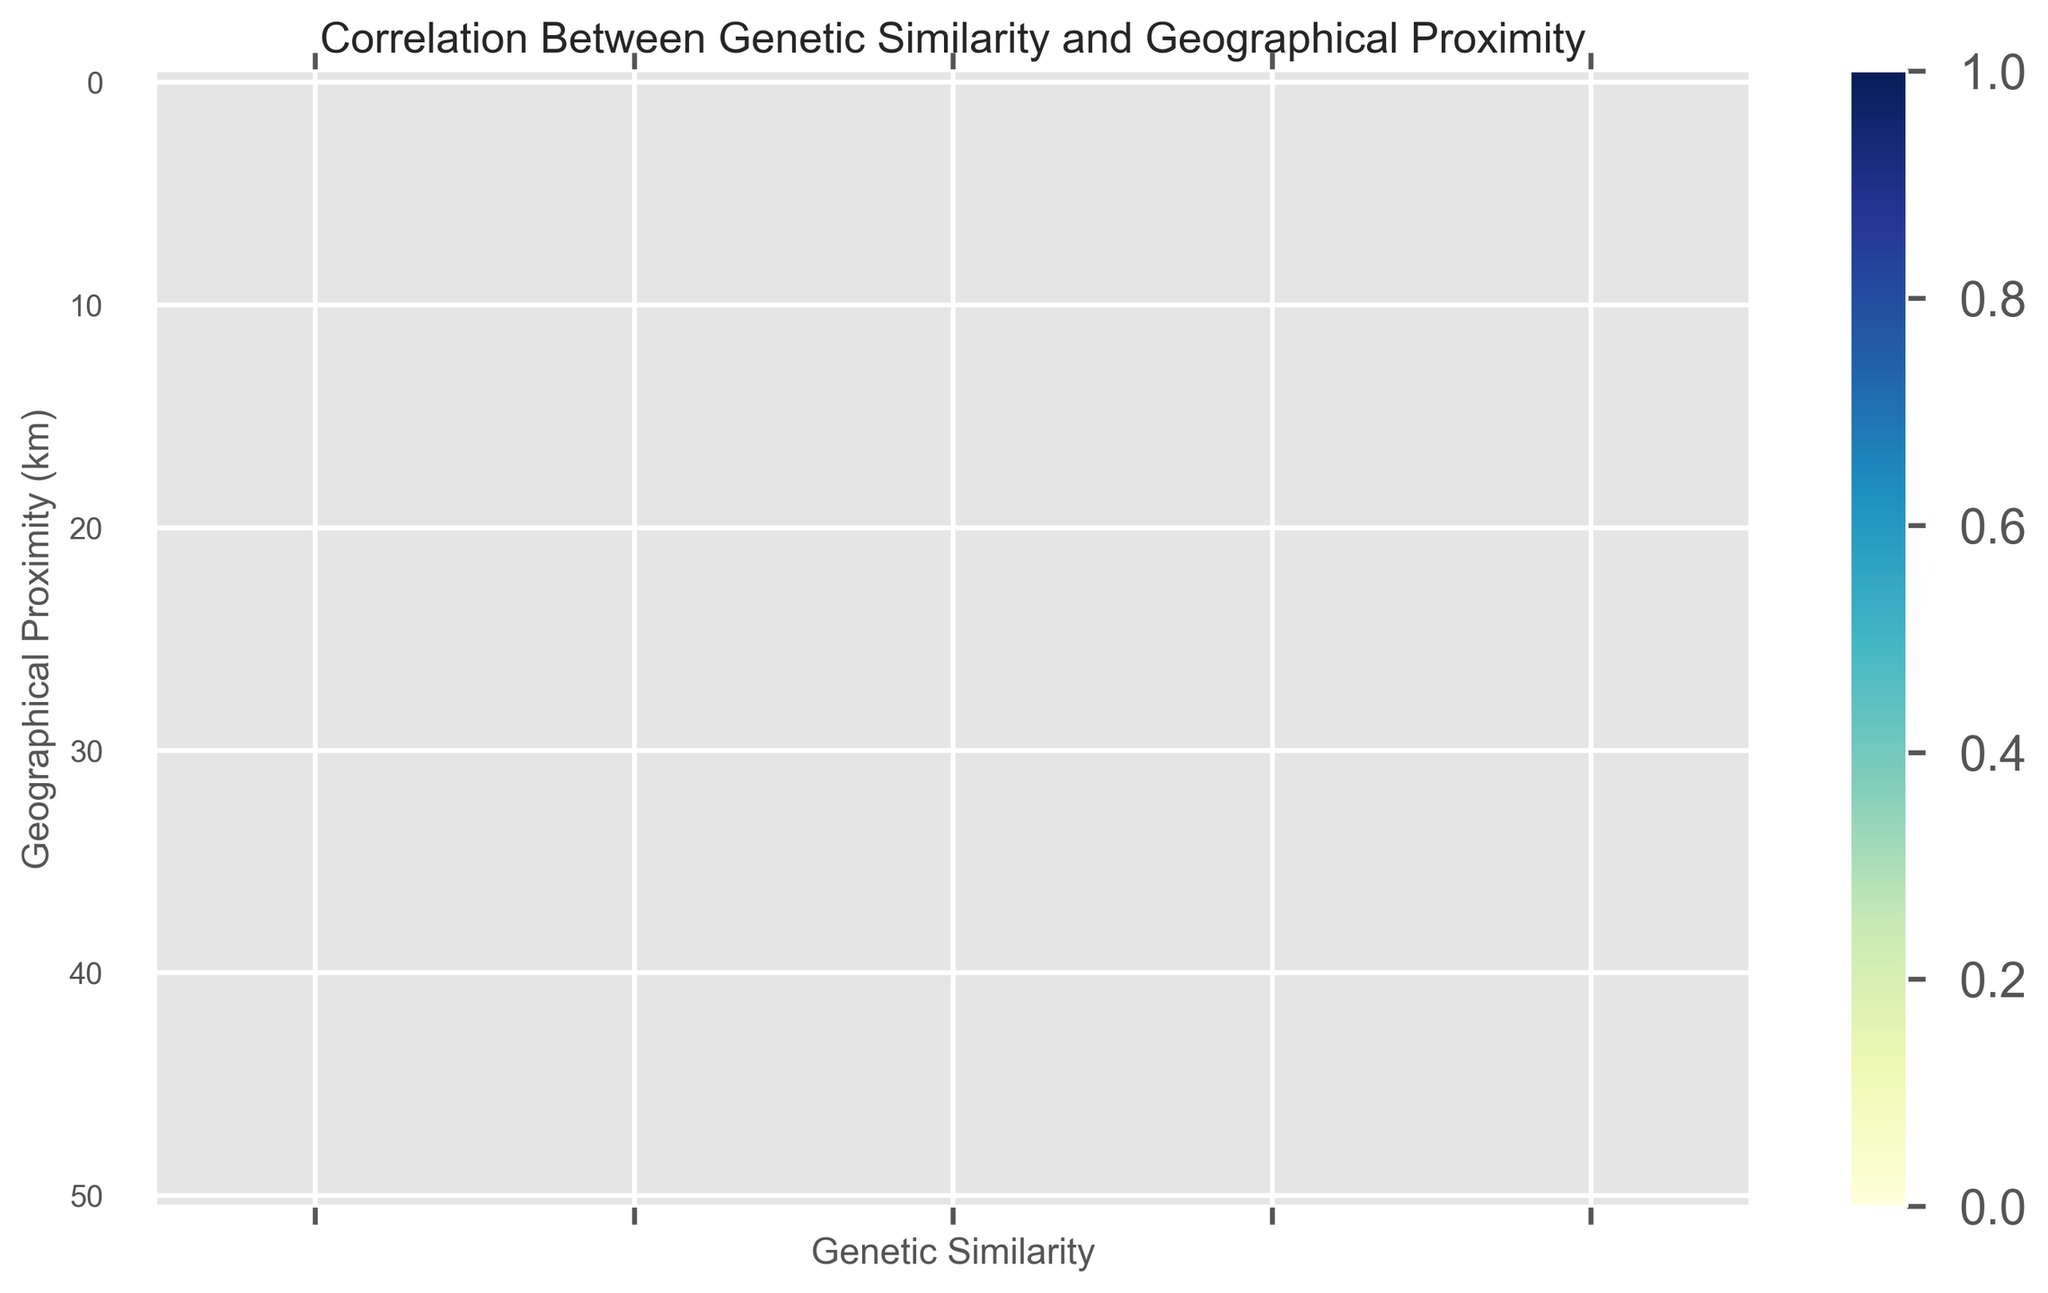What does the heatmap show about the relationship between genetic similarity and geographical proximity? The heatmap visually indicates that as geographical proximity increases (in km), genetic similarity tends to decrease. This is shown by a shift from lighter to darker colors as one moves from the top to the bottom of the heatmap.
Answer: Genetic similarity decreases with increasing geographical proximity At what geographical proximity do we see a sharp decrease in genetic similarity below 0.5? Genetic similarity drops below 0.5 around the geographical proximity of 90 km, as can be inferred from the heatmap's color gradient.
Answer: Around 90 km Which geographical proximity range shows the highest genetic similarity, and what is the approximate value? The highest genetic similarity is seen at the geographical proximity of 0 km with a genetic similarity value of 1.0, which is the lightest color in the heatmap.
Answer: 0 km, 1.0 How does the genetic similarity change between 100 km and 200 km of geographical proximity? By observing the heatmap's color gradient, genetic similarity decreases from approximately 0.45 at 100 km to about 0.24 at 200 km. This indicates a substantial decrease in genetic similarity with increasing distance.
Answer: Decreases from approx. 0.45 to 0.24 Do we observe any geographical proximity where the genetic similarity stabilizes to low values? If yes, specify the range and values. Yes, the heatmap shows that genetic similarity stabilizes to very low values (close to 0.01) beyond 420 km of geographical proximity. The colors in this range are consistently very dark.
Answer: Beyond 420 km, approx. 0.01 What can be inferred about genetic similarity at 310 km compared to 110 km? Comparing the shades of color at 310 km and 110 km on the heatmap, genetic similarity at 310 km (approx. 0.12) is significantly lower than at 110 km (approx. 0.42). Thus, increasing distance results in lower genetic similarity.
Answer: 310 km is significantly lower Identify the point at which genetic similarity first falls below 0.2. Referring to the heatmap, genetic similarity first falls below 0.2 around a geographical proximity of 240 km. This is the point where a noticeable color shift to darker shades begins.
Answer: Around 240 km What is the decline in genetic similarity per 10 km within the 50 to 150 km range? The genetic similarity at 50 km is 0.70, and at 150 km, it is 0.32. The decline per 10 km can be calculated by (0.70 - 0.32) / ((150 - 50) / 10) which equals approximately 0.038.
Answer: Approx. 0.038 per 10 km Are there any visual patterns in the heatmap that suggest potential outliers or anomalies? The heatmap does not show any abrupt changes or isolated color shifts, indicating no visual patterns that suggest outliers or anomalies. The transition from lighter to darker shades appears smooth and consistent.
Answer: No outliers or anomalies 